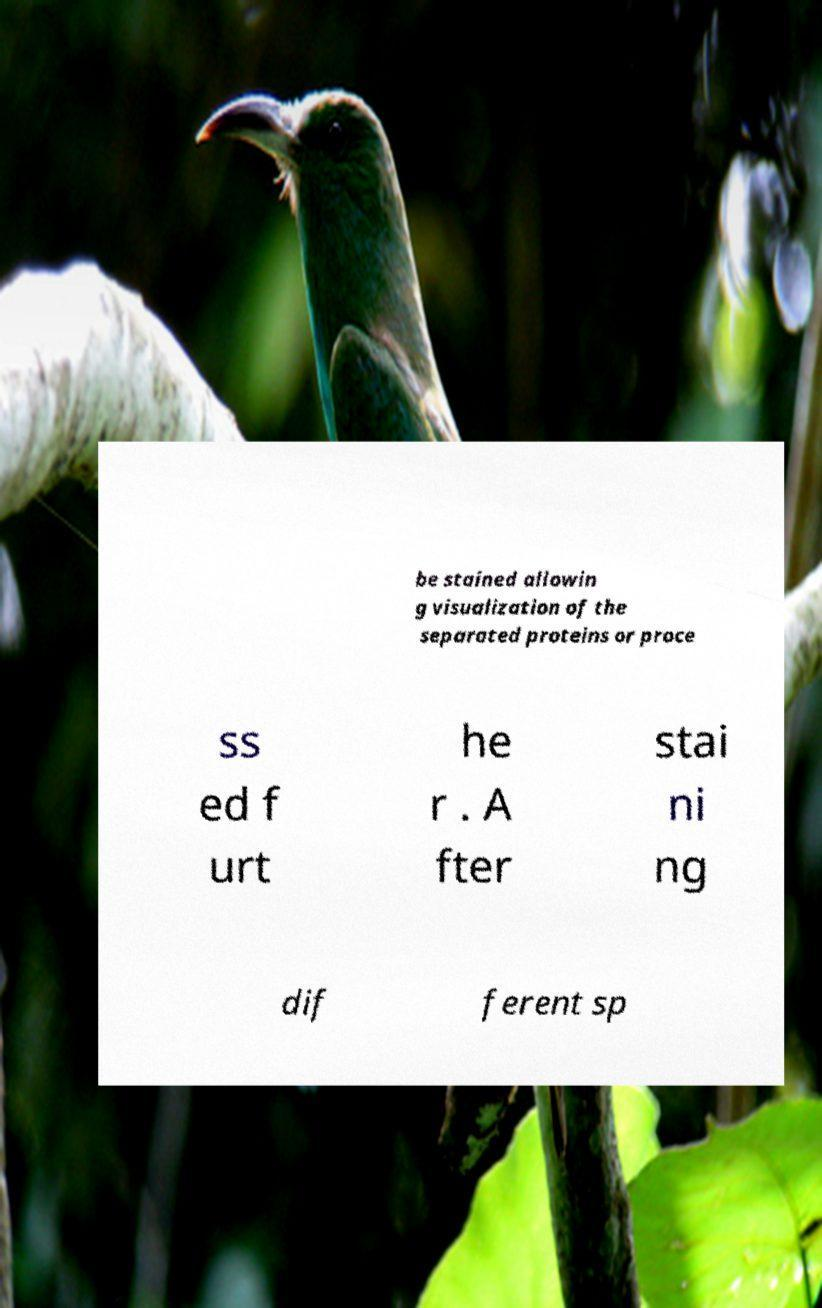What messages or text are displayed in this image? I need them in a readable, typed format. be stained allowin g visualization of the separated proteins or proce ss ed f urt he r . A fter stai ni ng dif ferent sp 